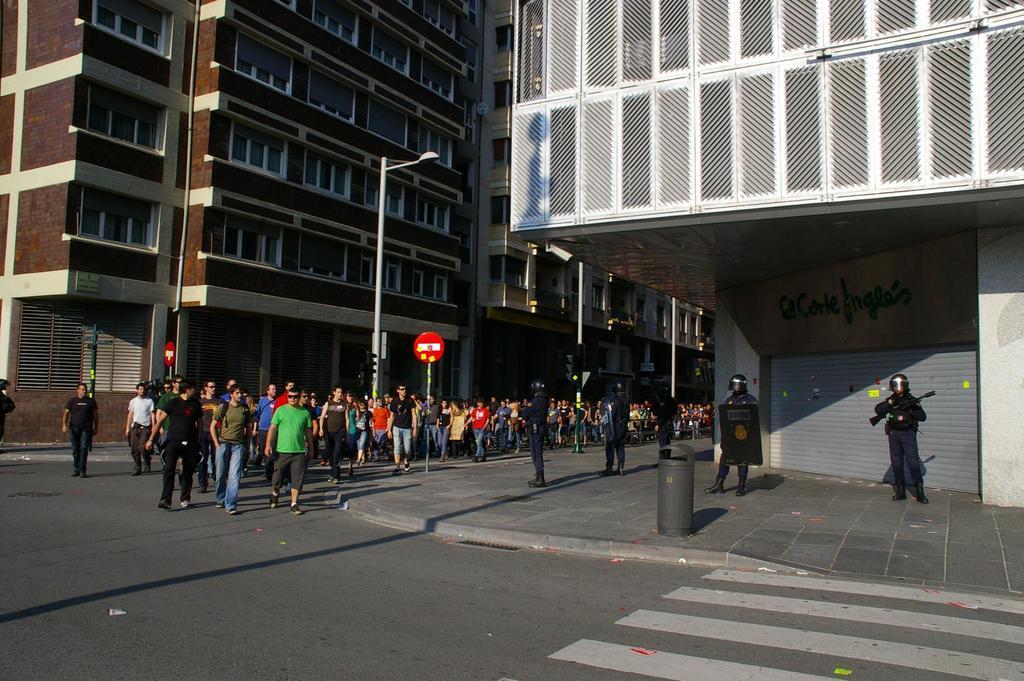Could you give a brief overview of what you see in this image? In the picture we can see a street with a road on it, we can see zebra lines and beside the road we can see a path on it, we can see a dustbin and some people standing, holding guns and they are with helmets and on the path we can see a pole with stop board and on the road we can see many people are walking and coming and to the both the sides of the people we can see buildings with many floors and windows to it and we can also see a pole with light. 